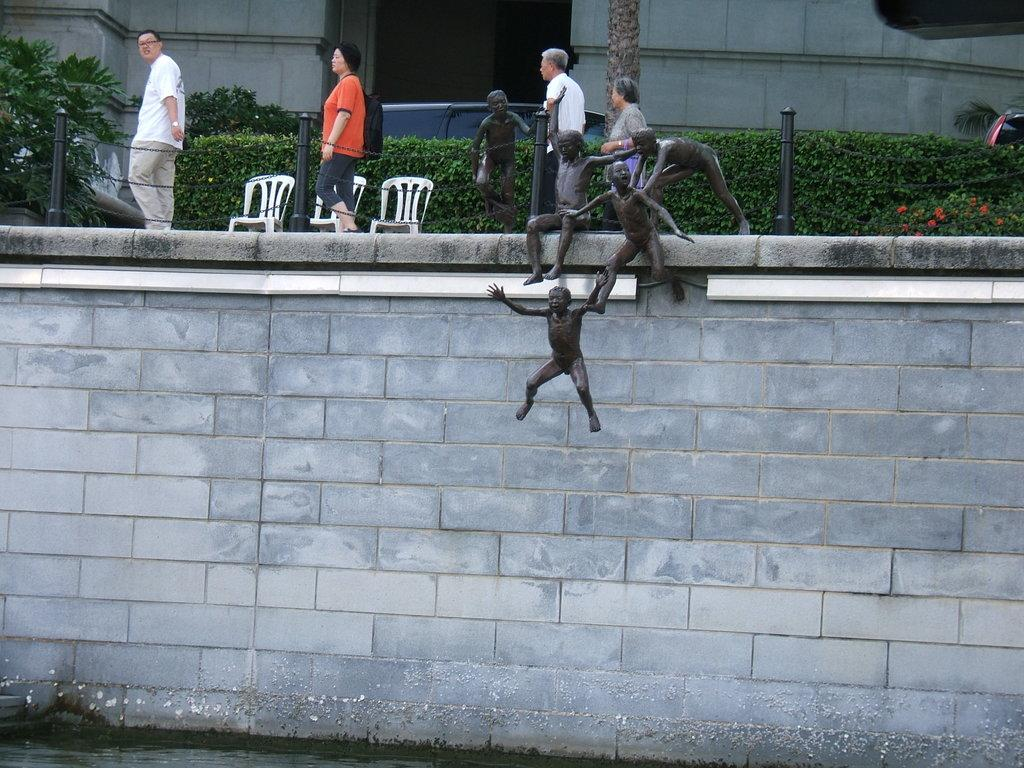How many people are in the image? There are three people in the image. What can be seen in the background of the image? In the background of the image, there are walls and a tree trunk. What type of objects are present in the image? There are sculptures, poles, chains, plants, and chairs in the image. What type of lunchroom is visible in the image? There is no lunchroom present in the image. What substance is being used by the visitors in the image? There are no visitors present in the image, and no substance is being used. 